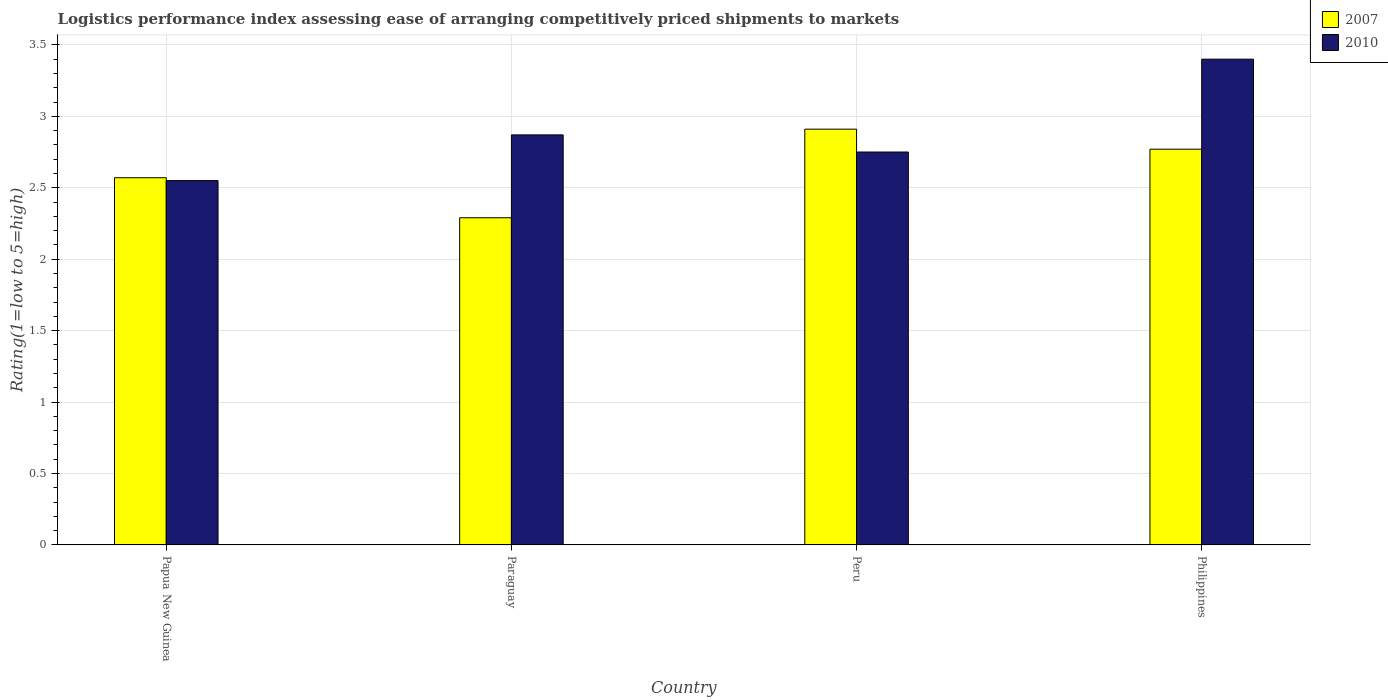How many different coloured bars are there?
Your response must be concise. 2. How many groups of bars are there?
Your answer should be very brief. 4. Are the number of bars per tick equal to the number of legend labels?
Give a very brief answer. Yes. Are the number of bars on each tick of the X-axis equal?
Ensure brevity in your answer.  Yes. How many bars are there on the 3rd tick from the left?
Make the answer very short. 2. How many bars are there on the 3rd tick from the right?
Provide a succinct answer. 2. What is the label of the 4th group of bars from the left?
Your response must be concise. Philippines. In how many cases, is the number of bars for a given country not equal to the number of legend labels?
Ensure brevity in your answer.  0. What is the Logistic performance index in 2010 in Peru?
Provide a short and direct response. 2.75. Across all countries, what is the maximum Logistic performance index in 2007?
Offer a terse response. 2.91. Across all countries, what is the minimum Logistic performance index in 2007?
Keep it short and to the point. 2.29. In which country was the Logistic performance index in 2010 minimum?
Keep it short and to the point. Papua New Guinea. What is the total Logistic performance index in 2007 in the graph?
Make the answer very short. 10.54. What is the difference between the Logistic performance index in 2007 in Papua New Guinea and that in Philippines?
Ensure brevity in your answer.  -0.2. What is the difference between the Logistic performance index in 2007 in Papua New Guinea and the Logistic performance index in 2010 in Paraguay?
Keep it short and to the point. -0.3. What is the average Logistic performance index in 2010 per country?
Make the answer very short. 2.89. What is the difference between the Logistic performance index of/in 2010 and Logistic performance index of/in 2007 in Philippines?
Give a very brief answer. 0.63. In how many countries, is the Logistic performance index in 2010 greater than 1?
Provide a short and direct response. 4. What is the ratio of the Logistic performance index in 2010 in Peru to that in Philippines?
Provide a succinct answer. 0.81. Is the Logistic performance index in 2007 in Paraguay less than that in Philippines?
Offer a terse response. Yes. Is the difference between the Logistic performance index in 2010 in Papua New Guinea and Philippines greater than the difference between the Logistic performance index in 2007 in Papua New Guinea and Philippines?
Ensure brevity in your answer.  No. What is the difference between the highest and the second highest Logistic performance index in 2010?
Your response must be concise. -0.12. What is the difference between the highest and the lowest Logistic performance index in 2010?
Give a very brief answer. 0.85. In how many countries, is the Logistic performance index in 2007 greater than the average Logistic performance index in 2007 taken over all countries?
Keep it short and to the point. 2. What does the 2nd bar from the right in Philippines represents?
Keep it short and to the point. 2007. How many bars are there?
Provide a short and direct response. 8. How many countries are there in the graph?
Provide a short and direct response. 4. What is the difference between two consecutive major ticks on the Y-axis?
Offer a terse response. 0.5. Does the graph contain any zero values?
Give a very brief answer. No. Where does the legend appear in the graph?
Keep it short and to the point. Top right. What is the title of the graph?
Your response must be concise. Logistics performance index assessing ease of arranging competitively priced shipments to markets. What is the label or title of the Y-axis?
Your answer should be compact. Rating(1=low to 5=high). What is the Rating(1=low to 5=high) in 2007 in Papua New Guinea?
Keep it short and to the point. 2.57. What is the Rating(1=low to 5=high) in 2010 in Papua New Guinea?
Offer a terse response. 2.55. What is the Rating(1=low to 5=high) in 2007 in Paraguay?
Provide a short and direct response. 2.29. What is the Rating(1=low to 5=high) in 2010 in Paraguay?
Ensure brevity in your answer.  2.87. What is the Rating(1=low to 5=high) of 2007 in Peru?
Provide a succinct answer. 2.91. What is the Rating(1=low to 5=high) of 2010 in Peru?
Ensure brevity in your answer.  2.75. What is the Rating(1=low to 5=high) of 2007 in Philippines?
Ensure brevity in your answer.  2.77. Across all countries, what is the maximum Rating(1=low to 5=high) in 2007?
Keep it short and to the point. 2.91. Across all countries, what is the minimum Rating(1=low to 5=high) in 2007?
Offer a terse response. 2.29. Across all countries, what is the minimum Rating(1=low to 5=high) in 2010?
Your response must be concise. 2.55. What is the total Rating(1=low to 5=high) in 2007 in the graph?
Ensure brevity in your answer.  10.54. What is the total Rating(1=low to 5=high) of 2010 in the graph?
Your answer should be very brief. 11.57. What is the difference between the Rating(1=low to 5=high) of 2007 in Papua New Guinea and that in Paraguay?
Ensure brevity in your answer.  0.28. What is the difference between the Rating(1=low to 5=high) in 2010 in Papua New Guinea and that in Paraguay?
Offer a terse response. -0.32. What is the difference between the Rating(1=low to 5=high) in 2007 in Papua New Guinea and that in Peru?
Provide a succinct answer. -0.34. What is the difference between the Rating(1=low to 5=high) in 2010 in Papua New Guinea and that in Peru?
Give a very brief answer. -0.2. What is the difference between the Rating(1=low to 5=high) of 2010 in Papua New Guinea and that in Philippines?
Your answer should be very brief. -0.85. What is the difference between the Rating(1=low to 5=high) of 2007 in Paraguay and that in Peru?
Your answer should be very brief. -0.62. What is the difference between the Rating(1=low to 5=high) of 2010 in Paraguay and that in Peru?
Your answer should be very brief. 0.12. What is the difference between the Rating(1=low to 5=high) in 2007 in Paraguay and that in Philippines?
Give a very brief answer. -0.48. What is the difference between the Rating(1=low to 5=high) in 2010 in Paraguay and that in Philippines?
Your answer should be very brief. -0.53. What is the difference between the Rating(1=low to 5=high) of 2007 in Peru and that in Philippines?
Make the answer very short. 0.14. What is the difference between the Rating(1=low to 5=high) in 2010 in Peru and that in Philippines?
Your answer should be compact. -0.65. What is the difference between the Rating(1=low to 5=high) in 2007 in Papua New Guinea and the Rating(1=low to 5=high) in 2010 in Paraguay?
Offer a very short reply. -0.3. What is the difference between the Rating(1=low to 5=high) of 2007 in Papua New Guinea and the Rating(1=low to 5=high) of 2010 in Peru?
Keep it short and to the point. -0.18. What is the difference between the Rating(1=low to 5=high) in 2007 in Papua New Guinea and the Rating(1=low to 5=high) in 2010 in Philippines?
Provide a short and direct response. -0.83. What is the difference between the Rating(1=low to 5=high) in 2007 in Paraguay and the Rating(1=low to 5=high) in 2010 in Peru?
Provide a succinct answer. -0.46. What is the difference between the Rating(1=low to 5=high) of 2007 in Paraguay and the Rating(1=low to 5=high) of 2010 in Philippines?
Provide a short and direct response. -1.11. What is the difference between the Rating(1=low to 5=high) in 2007 in Peru and the Rating(1=low to 5=high) in 2010 in Philippines?
Offer a very short reply. -0.49. What is the average Rating(1=low to 5=high) of 2007 per country?
Offer a terse response. 2.63. What is the average Rating(1=low to 5=high) of 2010 per country?
Provide a succinct answer. 2.89. What is the difference between the Rating(1=low to 5=high) of 2007 and Rating(1=low to 5=high) of 2010 in Paraguay?
Your answer should be compact. -0.58. What is the difference between the Rating(1=low to 5=high) of 2007 and Rating(1=low to 5=high) of 2010 in Peru?
Provide a short and direct response. 0.16. What is the difference between the Rating(1=low to 5=high) of 2007 and Rating(1=low to 5=high) of 2010 in Philippines?
Keep it short and to the point. -0.63. What is the ratio of the Rating(1=low to 5=high) in 2007 in Papua New Guinea to that in Paraguay?
Offer a terse response. 1.12. What is the ratio of the Rating(1=low to 5=high) of 2010 in Papua New Guinea to that in Paraguay?
Your answer should be compact. 0.89. What is the ratio of the Rating(1=low to 5=high) of 2007 in Papua New Guinea to that in Peru?
Make the answer very short. 0.88. What is the ratio of the Rating(1=low to 5=high) in 2010 in Papua New Guinea to that in Peru?
Give a very brief answer. 0.93. What is the ratio of the Rating(1=low to 5=high) in 2007 in Papua New Guinea to that in Philippines?
Give a very brief answer. 0.93. What is the ratio of the Rating(1=low to 5=high) of 2007 in Paraguay to that in Peru?
Offer a terse response. 0.79. What is the ratio of the Rating(1=low to 5=high) in 2010 in Paraguay to that in Peru?
Offer a terse response. 1.04. What is the ratio of the Rating(1=low to 5=high) of 2007 in Paraguay to that in Philippines?
Keep it short and to the point. 0.83. What is the ratio of the Rating(1=low to 5=high) in 2010 in Paraguay to that in Philippines?
Offer a terse response. 0.84. What is the ratio of the Rating(1=low to 5=high) of 2007 in Peru to that in Philippines?
Provide a succinct answer. 1.05. What is the ratio of the Rating(1=low to 5=high) of 2010 in Peru to that in Philippines?
Give a very brief answer. 0.81. What is the difference between the highest and the second highest Rating(1=low to 5=high) in 2007?
Your response must be concise. 0.14. What is the difference between the highest and the second highest Rating(1=low to 5=high) in 2010?
Give a very brief answer. 0.53. What is the difference between the highest and the lowest Rating(1=low to 5=high) of 2007?
Provide a short and direct response. 0.62. What is the difference between the highest and the lowest Rating(1=low to 5=high) in 2010?
Offer a terse response. 0.85. 